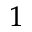Convert formula to latex. <formula><loc_0><loc_0><loc_500><loc_500>_ { 1 }</formula> 